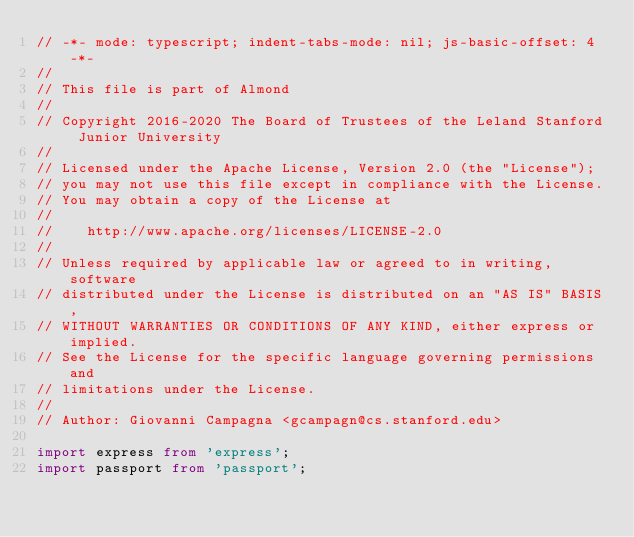<code> <loc_0><loc_0><loc_500><loc_500><_TypeScript_>// -*- mode: typescript; indent-tabs-mode: nil; js-basic-offset: 4 -*-
//
// This file is part of Almond
//
// Copyright 2016-2020 The Board of Trustees of the Leland Stanford Junior University
//
// Licensed under the Apache License, Version 2.0 (the "License");
// you may not use this file except in compliance with the License.
// You may obtain a copy of the License at
//
//    http://www.apache.org/licenses/LICENSE-2.0
//
// Unless required by applicable law or agreed to in writing, software
// distributed under the License is distributed on an "AS IS" BASIS,
// WITHOUT WARRANTIES OR CONDITIONS OF ANY KIND, either express or implied.
// See the License for the specific language governing permissions and
// limitations under the License.
//
// Author: Giovanni Campagna <gcampagn@cs.stanford.edu>

import express from 'express';
import passport from 'passport';</code> 